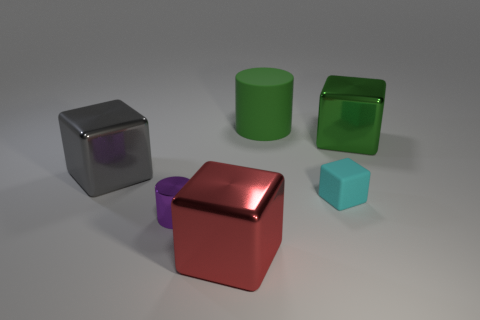Subtract all tiny blocks. How many blocks are left? 3 Add 2 tiny gray spheres. How many objects exist? 8 Subtract all gray blocks. How many blocks are left? 3 Subtract all cylinders. How many objects are left? 4 Subtract all yellow cubes. Subtract all cyan cylinders. How many cubes are left? 4 Subtract all red balls. How many purple cylinders are left? 1 Subtract all big purple shiny balls. Subtract all red metallic cubes. How many objects are left? 5 Add 3 green things. How many green things are left? 5 Add 2 big yellow rubber spheres. How many big yellow rubber spheres exist? 2 Subtract 0 yellow balls. How many objects are left? 6 